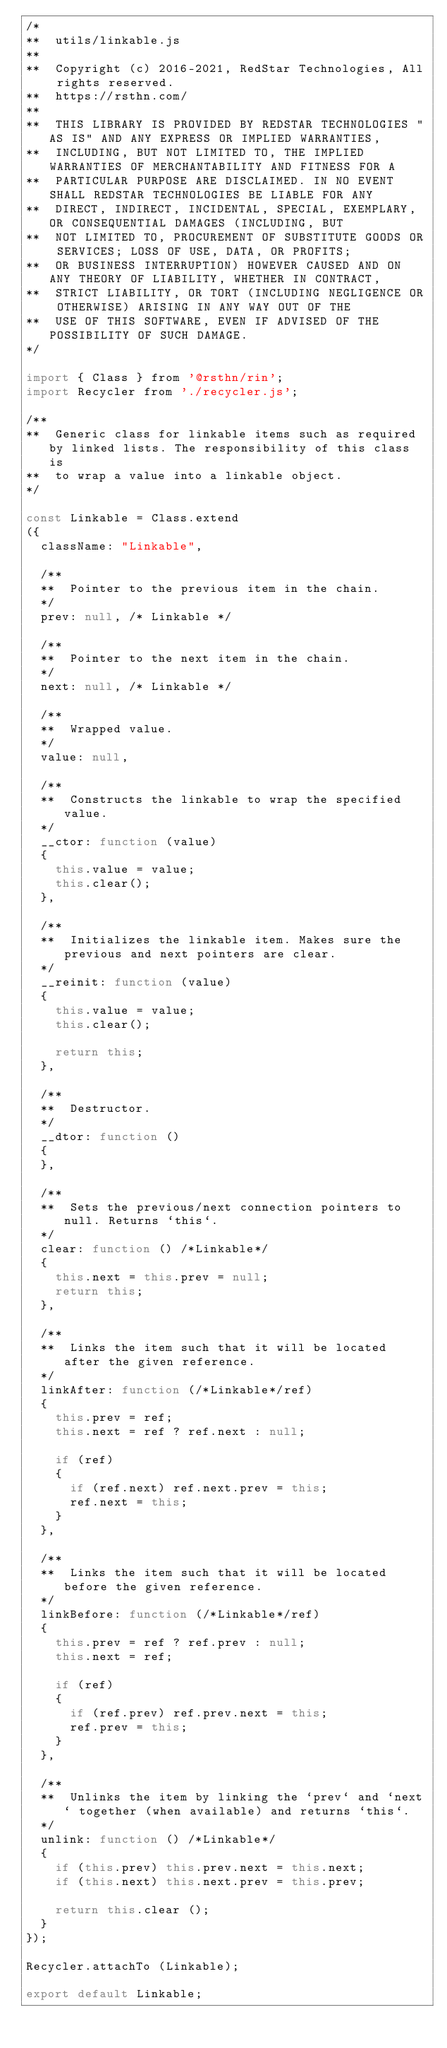Convert code to text. <code><loc_0><loc_0><loc_500><loc_500><_JavaScript_>/*
**	utils/linkable.js
**
**	Copyright (c) 2016-2021, RedStar Technologies, All rights reserved.
**	https://rsthn.com/
**
**	THIS LIBRARY IS PROVIDED BY REDSTAR TECHNOLOGIES "AS IS" AND ANY EXPRESS OR IMPLIED WARRANTIES,
**	INCLUDING, BUT NOT LIMITED TO, THE IMPLIED WARRANTIES OF MERCHANTABILITY AND FITNESS FOR A 
**	PARTICULAR PURPOSE ARE DISCLAIMED. IN NO EVENT SHALL REDSTAR TECHNOLOGIES BE LIABLE FOR ANY
**	DIRECT, INDIRECT, INCIDENTAL, SPECIAL, EXEMPLARY, OR CONSEQUENTIAL DAMAGES (INCLUDING, BUT 
**	NOT LIMITED TO, PROCUREMENT OF SUBSTITUTE GOODS OR SERVICES; LOSS OF USE, DATA, OR PROFITS; 
**	OR BUSINESS INTERRUPTION) HOWEVER CAUSED AND ON ANY THEORY OF LIABILITY, WHETHER IN CONTRACT, 
**	STRICT LIABILITY, OR TORT (INCLUDING NEGLIGENCE OR OTHERWISE) ARISING IN ANY WAY OUT OF THE
**	USE OF THIS SOFTWARE, EVEN IF ADVISED OF THE POSSIBILITY OF SUCH DAMAGE.
*/

import { Class } from '@rsthn/rin';
import Recycler from './recycler.js';

/**
**	Generic class for linkable items such as required by linked lists. The responsibility of this class is
**	to wrap a value into a linkable object.
*/

const Linkable = Class.extend
({
	className: "Linkable",

	/**
	**	Pointer to the previous item in the chain.
	*/
	prev: null, /* Linkable */

	/**
	**	Pointer to the next item in the chain.
	*/
	next: null, /* Linkable */

	/**
	**	Wrapped value.
	*/
	value: null,

	/**
	**	Constructs the linkable to wrap the specified value.
	*/
	__ctor: function (value)
	{
		this.value = value;
		this.clear();
	},

	/**
	**	Initializes the linkable item. Makes sure the previous and next pointers are clear.
	*/
	__reinit: function (value)
	{
		this.value = value;
		this.clear();

		return this;
	},

	/**
	**	Destructor.
	*/
	__dtor: function ()
	{
	},

	/**
	**	Sets the previous/next connection pointers to null. Returns `this`.
	*/
	clear: function () /*Linkable*/
	{
		this.next = this.prev = null;
		return this;
	},

	/**
	**	Links the item such that it will be located after the given reference.
	*/
	linkAfter: function (/*Linkable*/ref)
	{
		this.prev = ref;
		this.next = ref ? ref.next : null;

		if (ref)
		{
			if (ref.next) ref.next.prev = this;
			ref.next = this;
		}
	},

	/**
	**	Links the item such that it will be located before the given reference.
	*/
	linkBefore: function (/*Linkable*/ref)
	{
		this.prev = ref ? ref.prev : null;
		this.next = ref;

		if (ref)
		{
			if (ref.prev) ref.prev.next = this;
			ref.prev = this;
		}
	},

	/**
	**	Unlinks the item by linking the `prev` and `next` together (when available) and returns `this`.
	*/
	unlink: function () /*Linkable*/
	{
		if (this.prev) this.prev.next = this.next;
		if (this.next) this.next.prev = this.prev;

		return this.clear ();
	}
});

Recycler.attachTo (Linkable);

export default Linkable;
</code> 